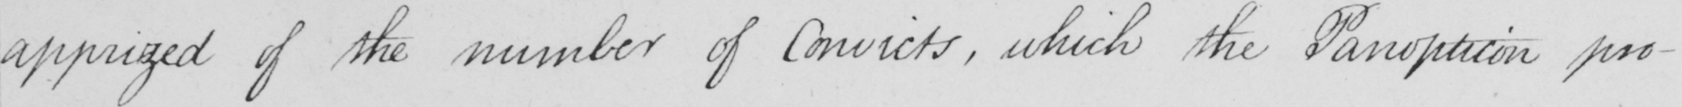Transcribe the text shown in this historical manuscript line. apprized of the number of Convicts , which the Panopticon pro- 